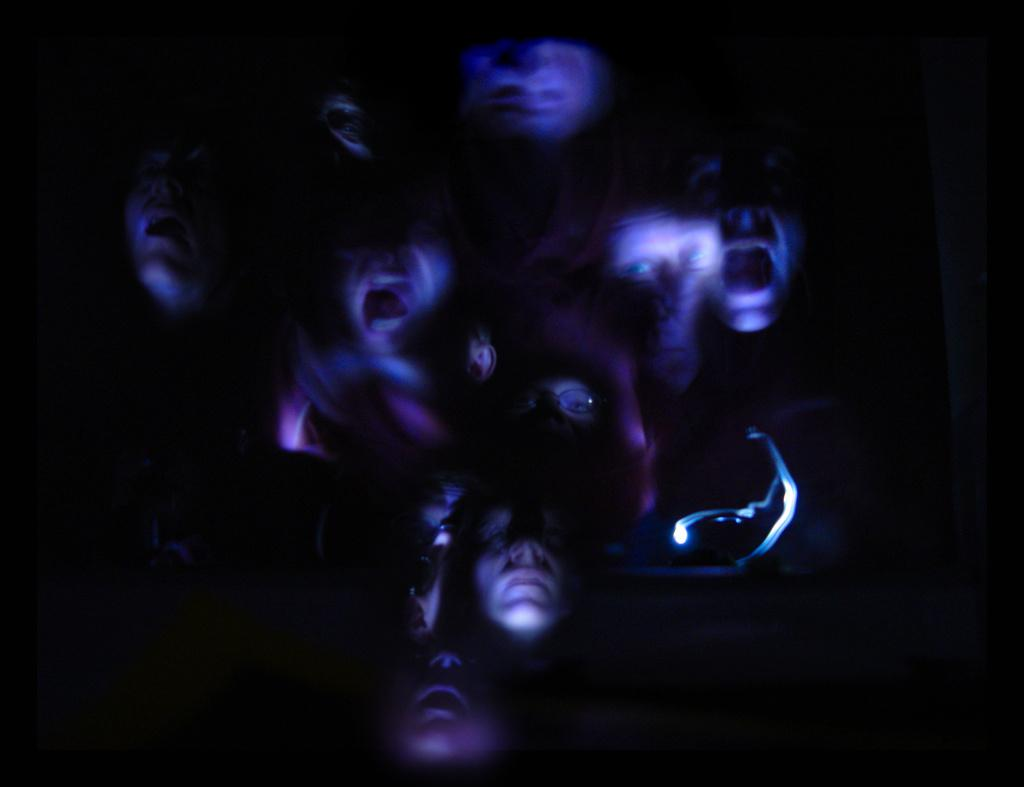What type of image is this? The image is an edited picture. What can be seen in the middle of the image? Faces of people are visible in the middle of the image. What type of finger can be seen in the image? There is no finger present in the image. Is there a locket visible in the image? There is no locket present in the image. Is there any lumber visible in the image? There is no lumber present in the image. 